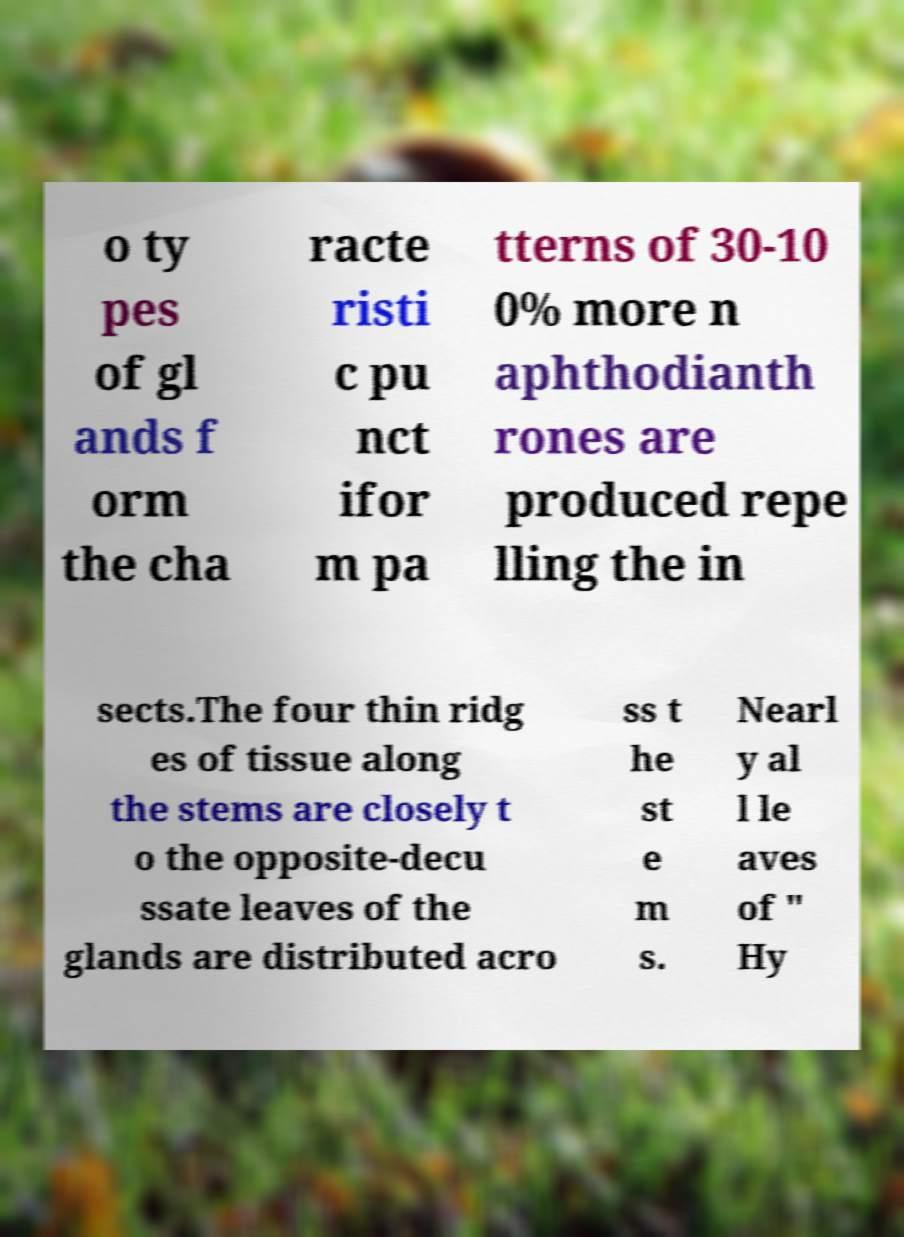What messages or text are displayed in this image? I need them in a readable, typed format. o ty pes of gl ands f orm the cha racte risti c pu nct ifor m pa tterns of 30-10 0% more n aphthodianth rones are produced repe lling the in sects.The four thin ridg es of tissue along the stems are closely t o the opposite-decu ssate leaves of the glands are distributed acro ss t he st e m s. Nearl y al l le aves of " Hy 